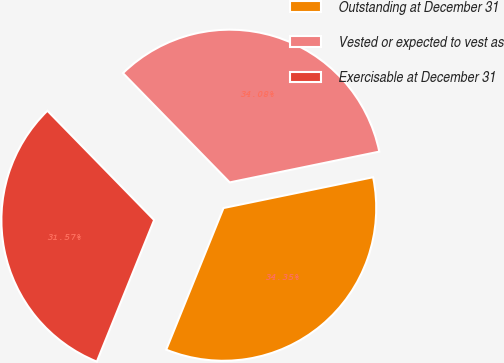<chart> <loc_0><loc_0><loc_500><loc_500><pie_chart><fcel>Outstanding at December 31<fcel>Vested or expected to vest as<fcel>Exercisable at December 31<nl><fcel>34.35%<fcel>34.08%<fcel>31.57%<nl></chart> 